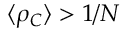<formula> <loc_0><loc_0><loc_500><loc_500>\langle \rho _ { C } \rangle > 1 / N</formula> 